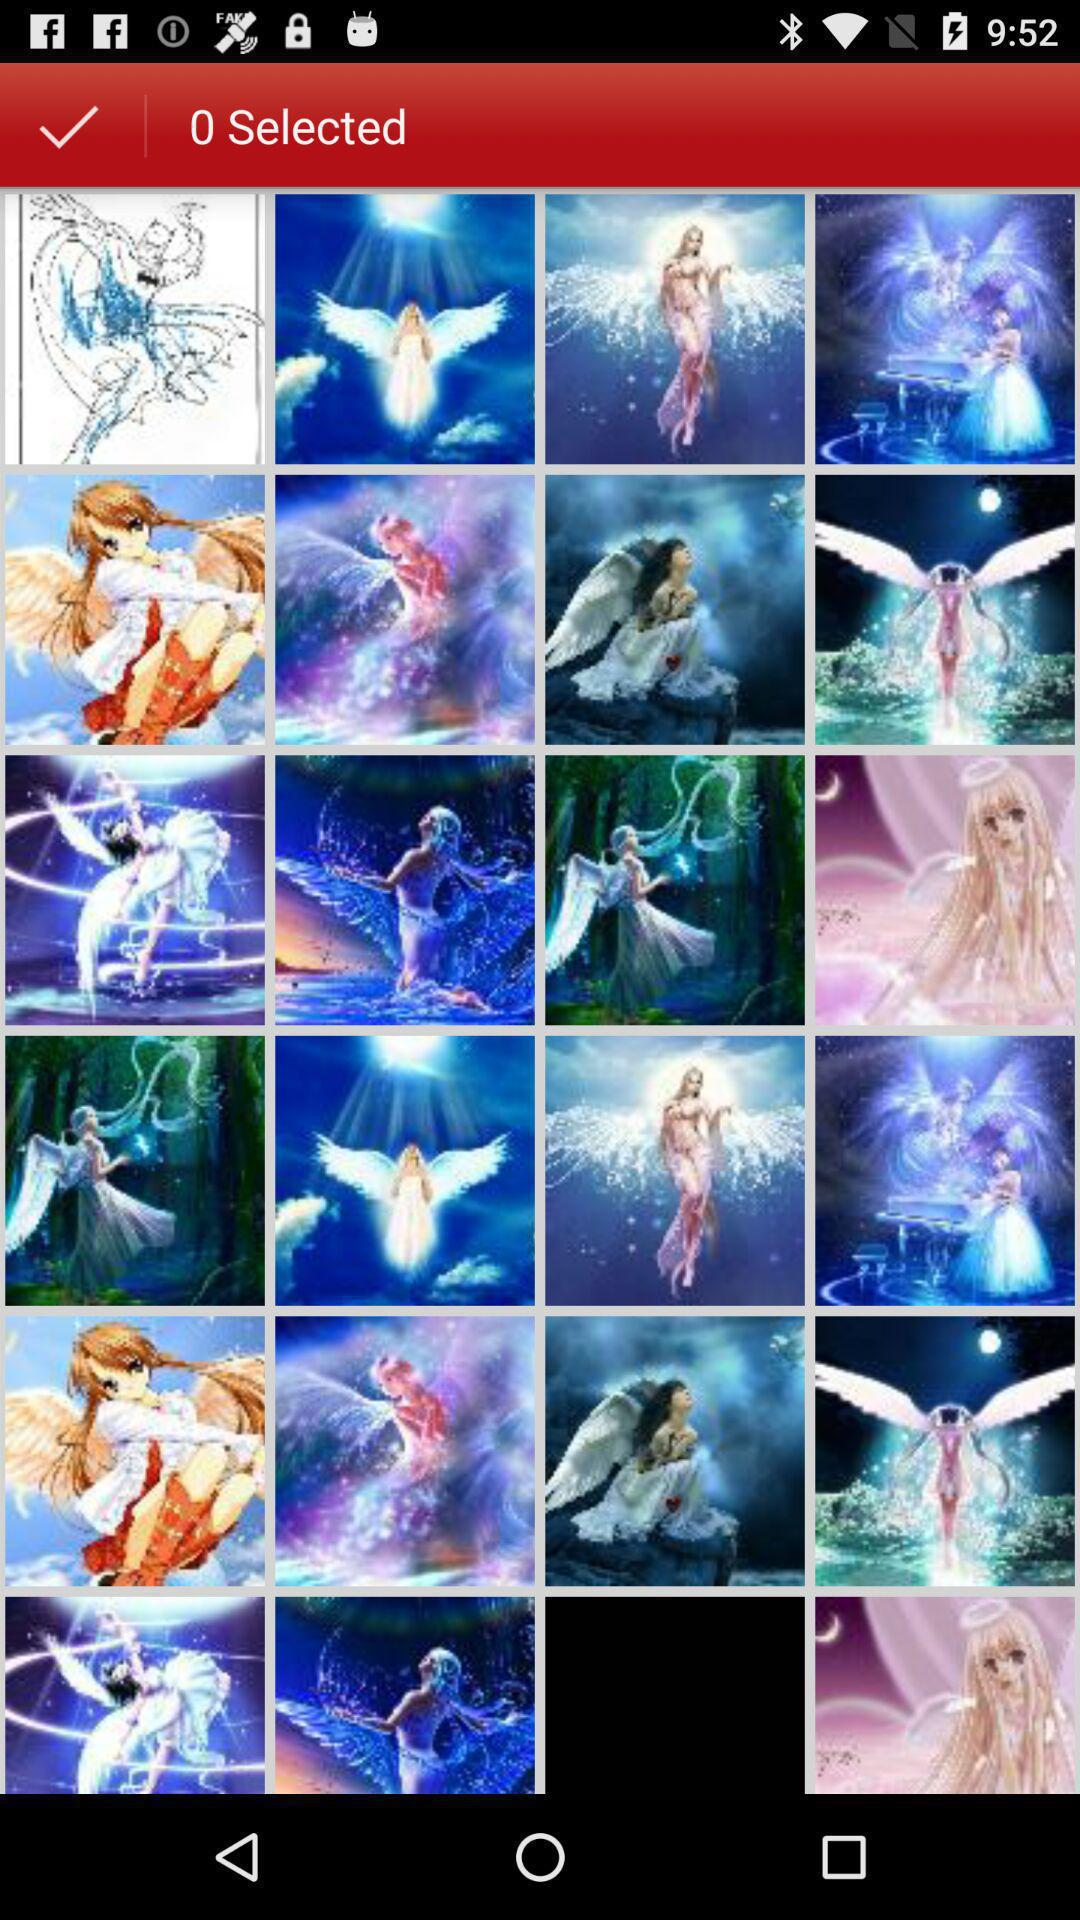How many images are selected? There is 0 image selected. 